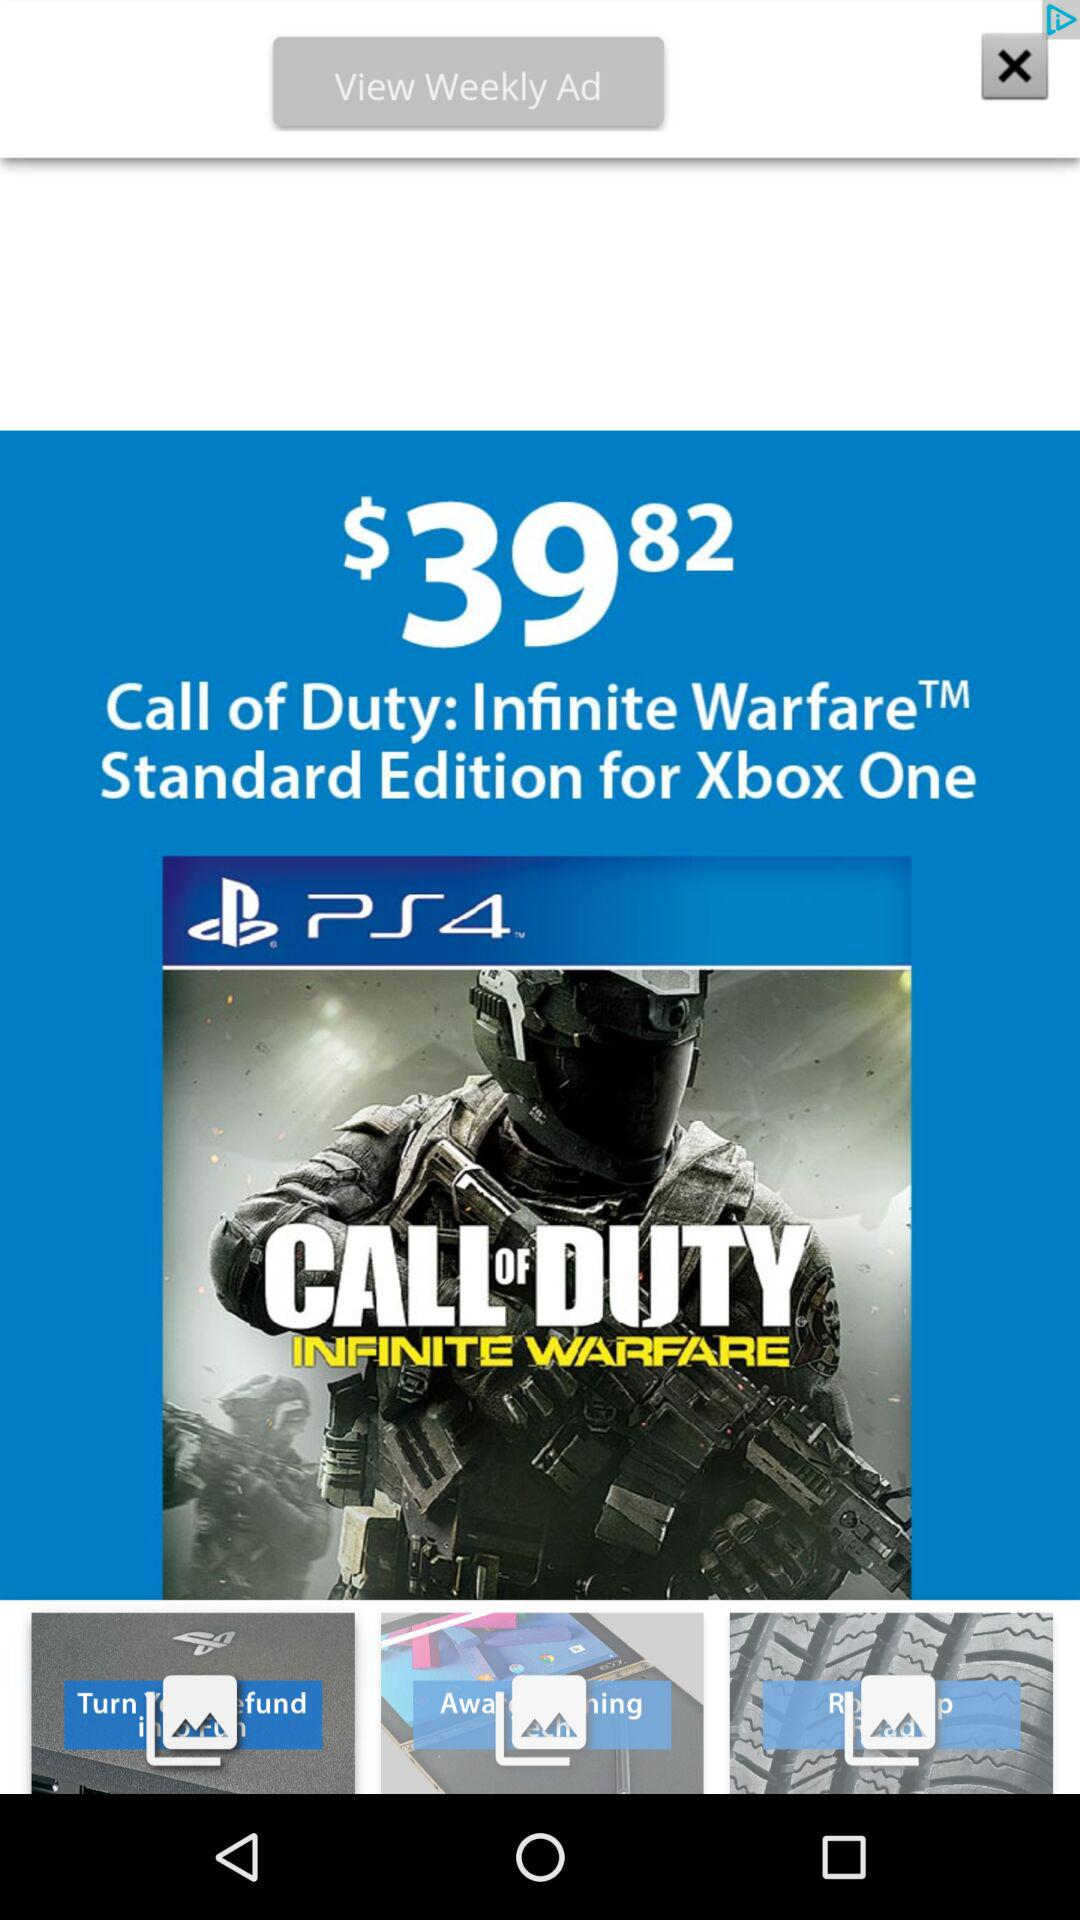What is the subscription amount for the "Call of Duty" game? The subscription amount is $39.82. 